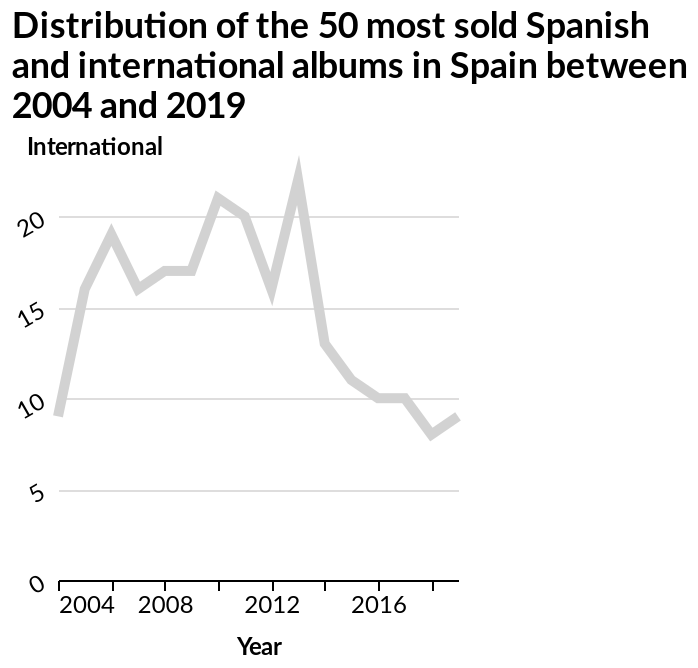<image>
What does the chart show about the number of Spanish and International albums sold in Spain?  The chart shows that the highest number of Spanish and International albums sold in Spain occurred around 2013. When did the peak in album sales in Spain occur?  The peak in album sales in Spain occurred around 2013. 